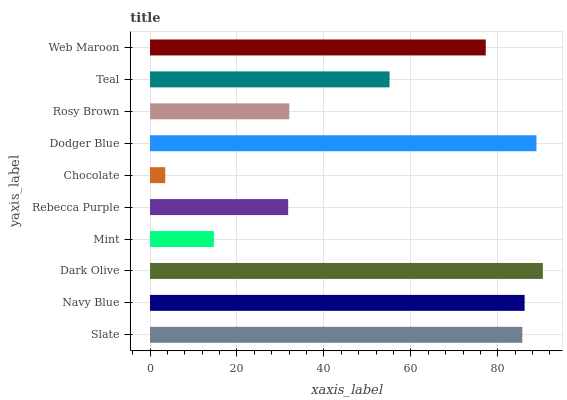Is Chocolate the minimum?
Answer yes or no. Yes. Is Dark Olive the maximum?
Answer yes or no. Yes. Is Navy Blue the minimum?
Answer yes or no. No. Is Navy Blue the maximum?
Answer yes or no. No. Is Navy Blue greater than Slate?
Answer yes or no. Yes. Is Slate less than Navy Blue?
Answer yes or no. Yes. Is Slate greater than Navy Blue?
Answer yes or no. No. Is Navy Blue less than Slate?
Answer yes or no. No. Is Web Maroon the high median?
Answer yes or no. Yes. Is Teal the low median?
Answer yes or no. Yes. Is Mint the high median?
Answer yes or no. No. Is Dark Olive the low median?
Answer yes or no. No. 